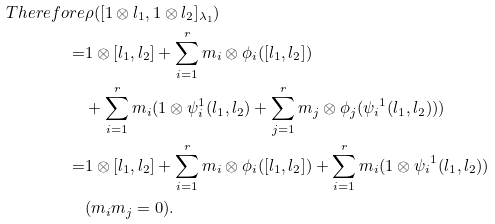Convert formula to latex. <formula><loc_0><loc_0><loc_500><loc_500>T h e r e f o r e & \rho ( [ 1 \otimes l _ { 1 } , 1 \otimes l _ { 2 } ] _ { \lambda _ { 1 } } ) \\ = & 1 \otimes [ l _ { 1 } , l _ { 2 } ] + \sum _ { i = 1 } ^ { r } m _ { i } \otimes \phi _ { i } ( [ l _ { 1 } , l _ { 2 } ] ) \\ & + \sum _ { i = 1 } ^ { r } m _ { i } ( 1 \otimes \psi _ { i } ^ { 1 } ( l _ { 1 } , l _ { 2 } ) + \sum _ { j = 1 } ^ { r } m _ { j } \otimes \phi _ { j } ( { \psi _ { i } } ^ { 1 } ( l _ { 1 } , l _ { 2 } ) ) ) \\ = & 1 \otimes [ l _ { 1 } , l _ { 2 } ] + \sum _ { i = 1 } ^ { r } m _ { i } \otimes \phi _ { i } ( [ l _ { 1 } , l _ { 2 } ] ) + \sum _ { i = 1 } ^ { r } m _ { i } ( 1 \otimes { \psi _ { i } } ^ { 1 } ( l _ { 1 } , l _ { 2 } ) ) \\ & ( m _ { i } m _ { j } = 0 ) .</formula> 